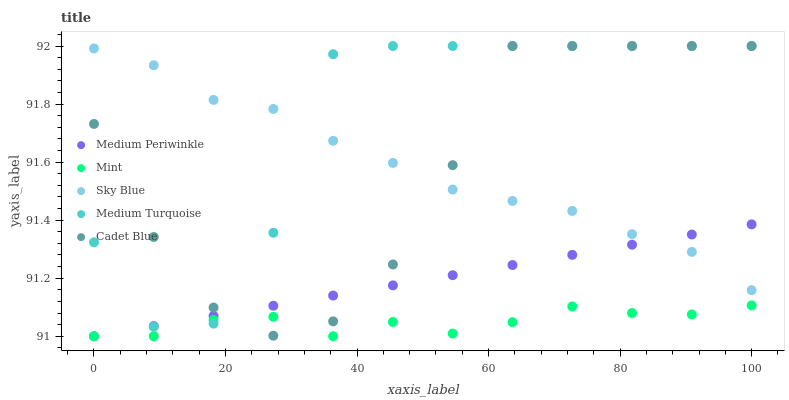Does Mint have the minimum area under the curve?
Answer yes or no. Yes. Does Medium Turquoise have the maximum area under the curve?
Answer yes or no. Yes. Does Cadet Blue have the minimum area under the curve?
Answer yes or no. No. Does Cadet Blue have the maximum area under the curve?
Answer yes or no. No. Is Medium Periwinkle the smoothest?
Answer yes or no. Yes. Is Medium Turquoise the roughest?
Answer yes or no. Yes. Is Cadet Blue the smoothest?
Answer yes or no. No. Is Cadet Blue the roughest?
Answer yes or no. No. Does Mint have the lowest value?
Answer yes or no. Yes. Does Cadet Blue have the lowest value?
Answer yes or no. No. Does Medium Turquoise have the highest value?
Answer yes or no. Yes. Does Medium Periwinkle have the highest value?
Answer yes or no. No. Is Mint less than Sky Blue?
Answer yes or no. Yes. Is Sky Blue greater than Mint?
Answer yes or no. Yes. Does Medium Turquoise intersect Sky Blue?
Answer yes or no. Yes. Is Medium Turquoise less than Sky Blue?
Answer yes or no. No. Is Medium Turquoise greater than Sky Blue?
Answer yes or no. No. Does Mint intersect Sky Blue?
Answer yes or no. No. 